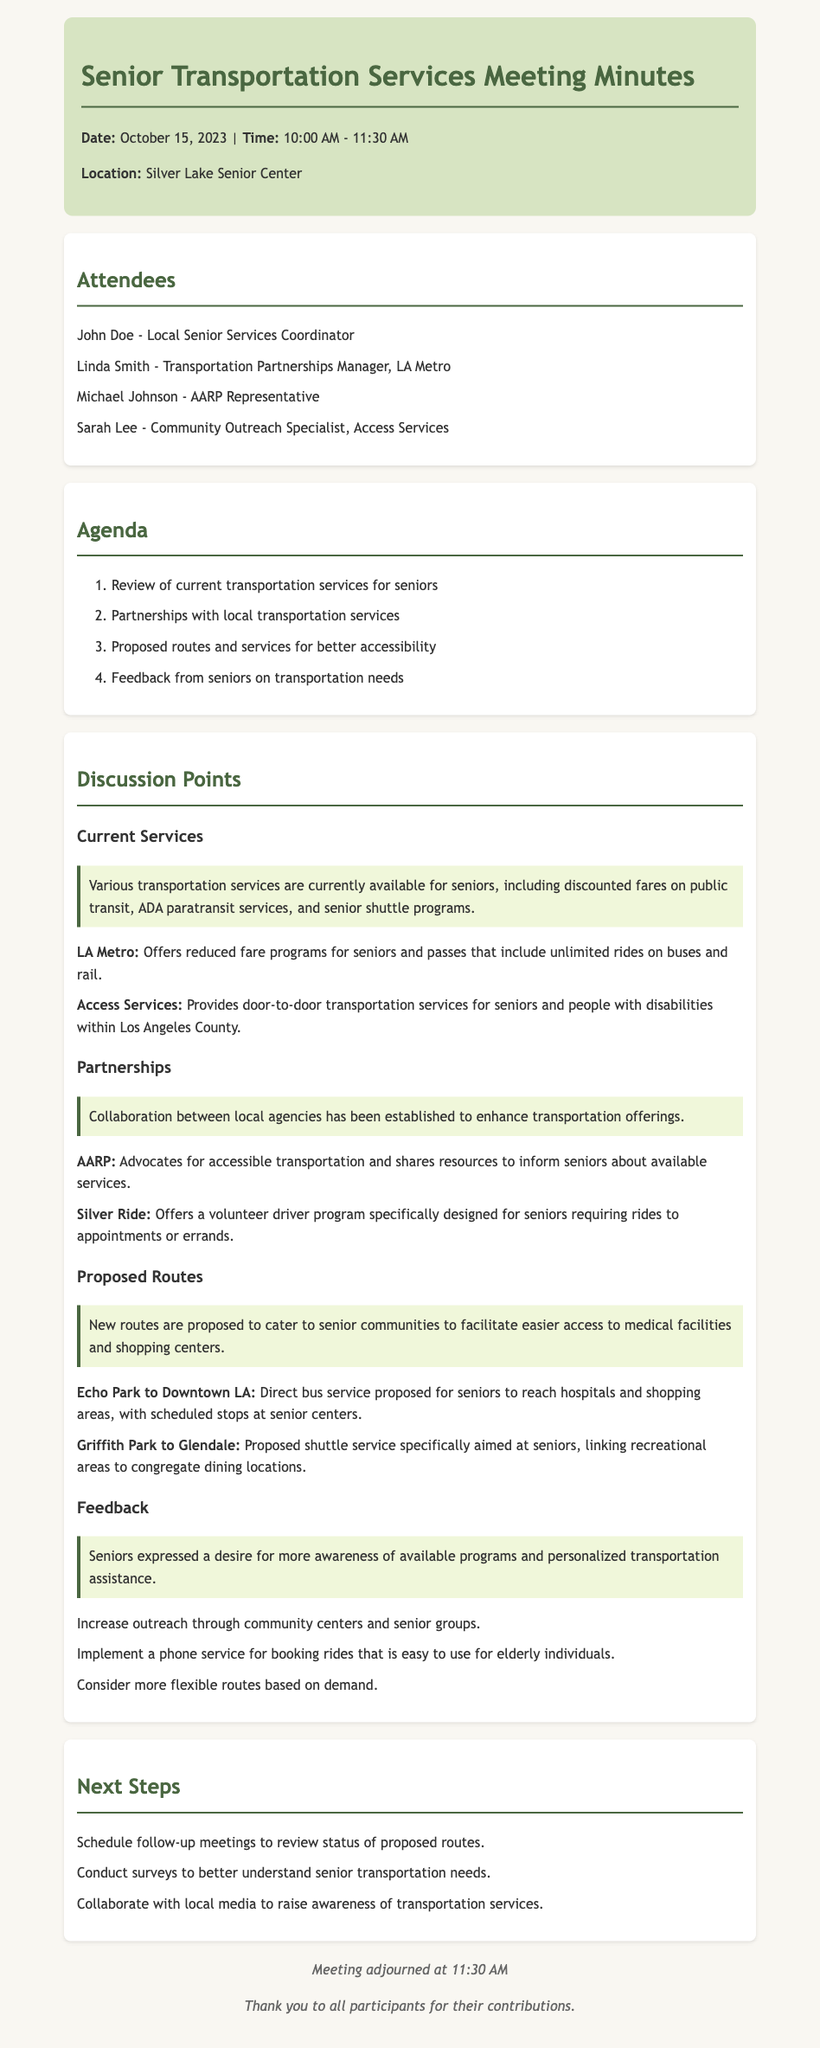What is the date of the meeting? The date of the meeting is stated in the header of the document.
Answer: October 15, 2023 Who is the Transportation Partnerships Manager? The document lists attendees, mentioning their roles and names.
Answer: Linda Smith What transportation service provides door-to-door services? The highlight section mentions specific services available for seniors.
Answer: Access Services What proposed route connects Echo Park to Downtown LA? The document outlines the proposed routes with specific descriptions.
Answer: Direct bus service What did seniors express a desire for? The feedback section captures the sentiments of seniors regarding transportation services.
Answer: More awareness of available programs How long did the meeting last? The starting and ending times indicate the duration of the meeting.
Answer: 1 hour 30 minutes Which organization offers a volunteer driver program? Partnerships listed in the document reference this specific service.
Answer: Silver Ride How is awareness expected to be raised? Next steps suggest collaborating with local media for this purpose.
Answer: Collaborate with local media 